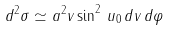Convert formula to latex. <formula><loc_0><loc_0><loc_500><loc_500>d ^ { 2 } \sigma \simeq a ^ { 2 } v \sin ^ { 2 } \, u _ { 0 } \, d v \, d \varphi</formula> 